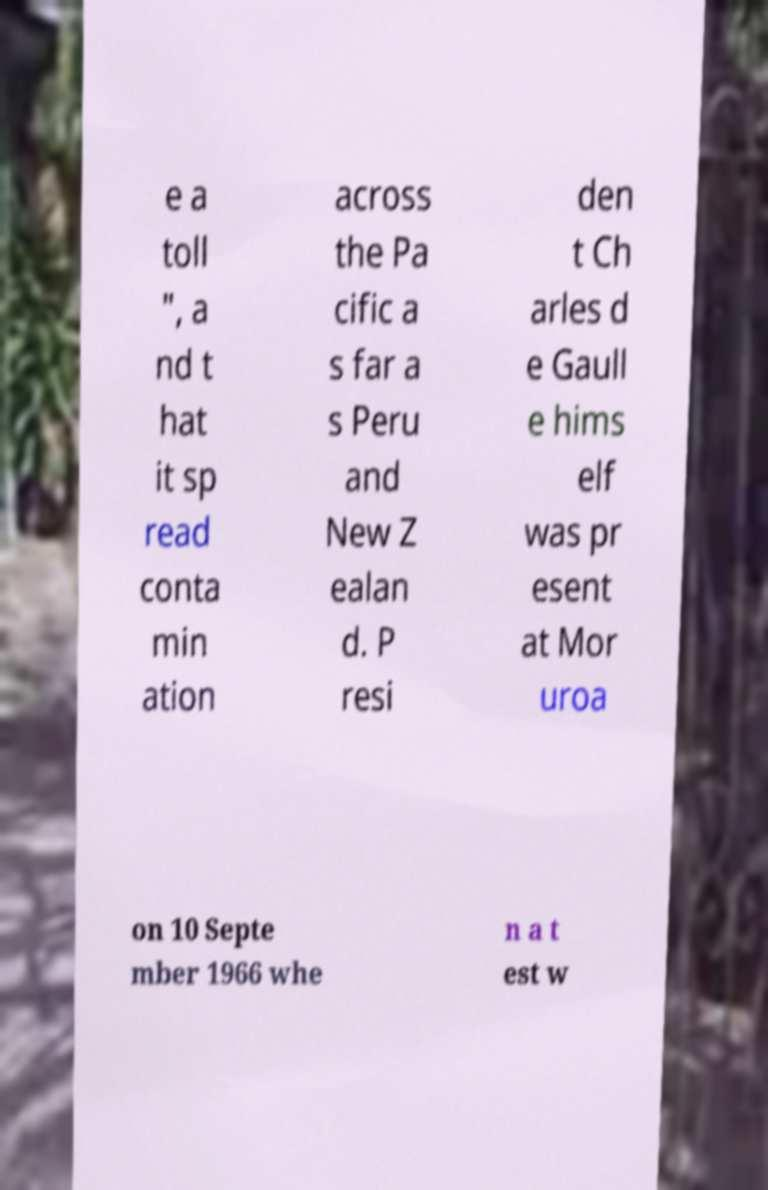Please read and relay the text visible in this image. What does it say? e a toll ", a nd t hat it sp read conta min ation across the Pa cific a s far a s Peru and New Z ealan d. P resi den t Ch arles d e Gaull e hims elf was pr esent at Mor uroa on 10 Septe mber 1966 whe n a t est w 